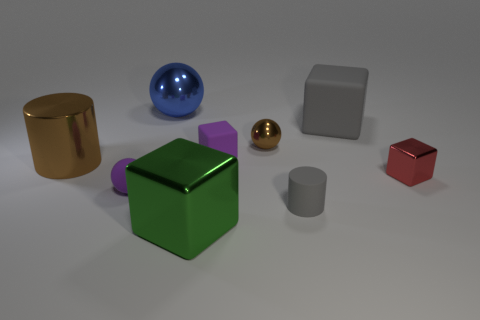What shape is the large rubber object that is the same color as the matte cylinder?
Your answer should be very brief. Cube. What number of blue things have the same material as the big cylinder?
Provide a short and direct response. 1. What color is the small rubber ball?
Keep it short and to the point. Purple. What is the color of the shiny cube that is the same size as the gray matte block?
Offer a very short reply. Green. Is there a rubber cube of the same color as the tiny rubber cylinder?
Your answer should be compact. Yes. There is a tiny matte object that is to the right of the small brown ball; does it have the same shape as the gray thing right of the tiny rubber cylinder?
Provide a short and direct response. No. There is a object that is the same color as the big matte block; what is its size?
Make the answer very short. Small. What number of other things are the same size as the gray matte cylinder?
Your answer should be compact. 4. Do the big shiny sphere and the tiny ball left of the green block have the same color?
Your answer should be very brief. No. Is the number of matte things that are in front of the big green thing less than the number of big blue shiny balls in front of the small gray cylinder?
Your answer should be very brief. No. 